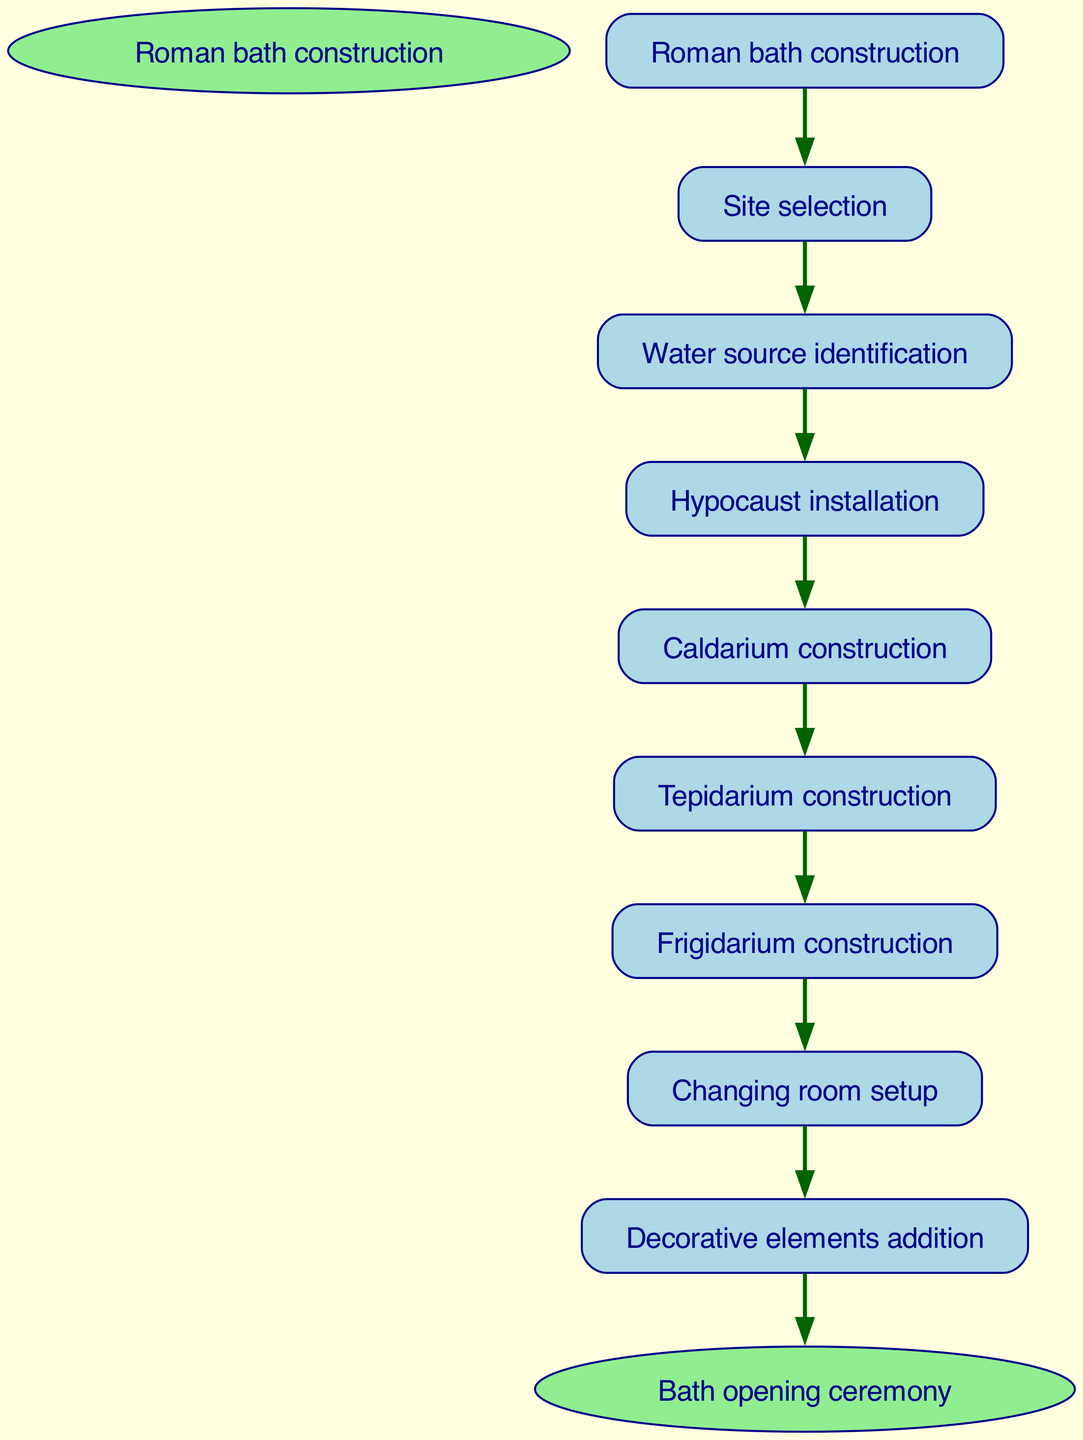What is the first step in the process? The diagram shows 'Roman bath construction' as the starting point, from which the first action is 'Site selection'. This can be verified as it is the first node that follows the start node.
Answer: Site selection How many main construction steps are there? By counting the nodes listed between 'Roman bath construction' and 'Bath opening ceremony', we find a total of eight main steps, which includes 'Site selection' through to 'Decorative elements addition'.
Answer: Eight What follows the 'Caldarium construction'? The flow chart indicates that the next step after 'Caldarium construction' is 'Tepidarium construction'. This can be deduced from the edge that connects the two nodes in the diagram.
Answer: Tepidarium construction What is the last step before the bath opening ceremony? From the diagram, the last step before reaching 'Bath opening ceremony' is 'Decorative elements addition'. This is determined as it is the final node leading to the end node.
Answer: Decorative elements addition What is the relationship between 'Water source identification' and 'Hypocaust installation'? The diagram displays a direct flow from 'Water source identification' to 'Hypocaust installation', indicating that the first must be completed before the latter can begin. This shows a sequential relationship between these two steps.
Answer: Sequential relationship How many edges are in the flow diagram? Analyzing the edges connecting the nodes, there are a total of eight edges, each representing a connection between steps in the construction process from start to finish.
Answer: Eight Which step does the 'Changing room setup' lead to? According to the flowchart, 'Changing room setup' directly leads to 'Decorative elements addition', as this is the following node in the sequence as indicated by the edge.
Answer: Decorative elements addition What is the final outcome of the process? The end node of the flowchart is labeled 'Bath opening ceremony', signifying that this is the culmination of all prior construction activities, thus marking the completion of the bath facility.
Answer: Bath opening ceremony 